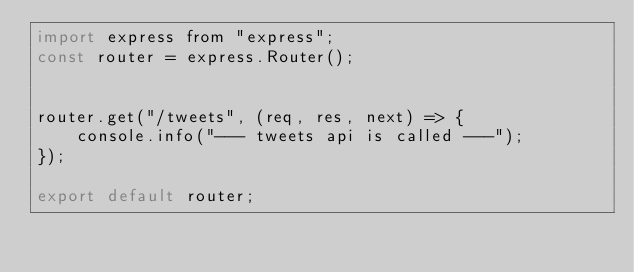<code> <loc_0><loc_0><loc_500><loc_500><_JavaScript_>import express from "express";
const router = express.Router();


router.get("/tweets", (req, res, next) => {
    console.info("--- tweets api is called ---");
});

export default router;
</code> 